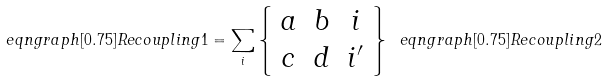Convert formula to latex. <formula><loc_0><loc_0><loc_500><loc_500>\ e q n g r a p h [ 0 . 7 5 ] { R e c o u p l i n g 1 } = \sum _ { i } \left \{ \begin{array} { c c c } a & b & i \\ c & d & i ^ { \prime } \end{array} \right \} \ e q n g r a p h [ 0 . 7 5 ] { R e c o u p l i n g 2 }</formula> 